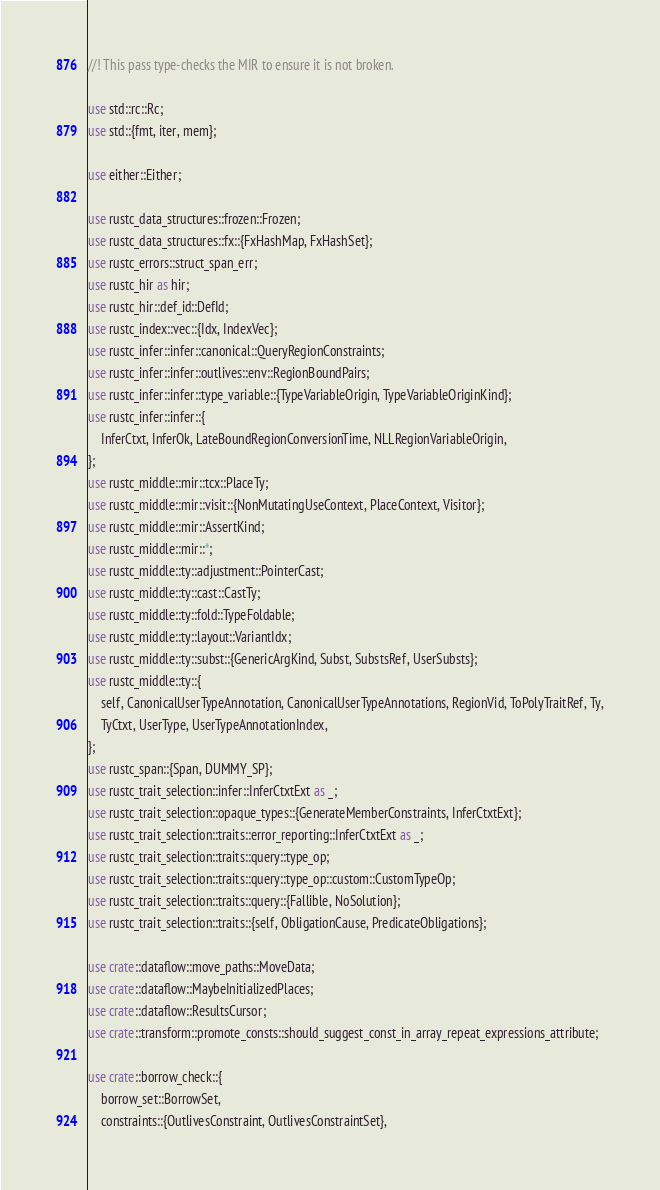Convert code to text. <code><loc_0><loc_0><loc_500><loc_500><_Rust_>//! This pass type-checks the MIR to ensure it is not broken.

use std::rc::Rc;
use std::{fmt, iter, mem};

use either::Either;

use rustc_data_structures::frozen::Frozen;
use rustc_data_structures::fx::{FxHashMap, FxHashSet};
use rustc_errors::struct_span_err;
use rustc_hir as hir;
use rustc_hir::def_id::DefId;
use rustc_index::vec::{Idx, IndexVec};
use rustc_infer::infer::canonical::QueryRegionConstraints;
use rustc_infer::infer::outlives::env::RegionBoundPairs;
use rustc_infer::infer::type_variable::{TypeVariableOrigin, TypeVariableOriginKind};
use rustc_infer::infer::{
    InferCtxt, InferOk, LateBoundRegionConversionTime, NLLRegionVariableOrigin,
};
use rustc_middle::mir::tcx::PlaceTy;
use rustc_middle::mir::visit::{NonMutatingUseContext, PlaceContext, Visitor};
use rustc_middle::mir::AssertKind;
use rustc_middle::mir::*;
use rustc_middle::ty::adjustment::PointerCast;
use rustc_middle::ty::cast::CastTy;
use rustc_middle::ty::fold::TypeFoldable;
use rustc_middle::ty::layout::VariantIdx;
use rustc_middle::ty::subst::{GenericArgKind, Subst, SubstsRef, UserSubsts};
use rustc_middle::ty::{
    self, CanonicalUserTypeAnnotation, CanonicalUserTypeAnnotations, RegionVid, ToPolyTraitRef, Ty,
    TyCtxt, UserType, UserTypeAnnotationIndex,
};
use rustc_span::{Span, DUMMY_SP};
use rustc_trait_selection::infer::InferCtxtExt as _;
use rustc_trait_selection::opaque_types::{GenerateMemberConstraints, InferCtxtExt};
use rustc_trait_selection::traits::error_reporting::InferCtxtExt as _;
use rustc_trait_selection::traits::query::type_op;
use rustc_trait_selection::traits::query::type_op::custom::CustomTypeOp;
use rustc_trait_selection::traits::query::{Fallible, NoSolution};
use rustc_trait_selection::traits::{self, ObligationCause, PredicateObligations};

use crate::dataflow::move_paths::MoveData;
use crate::dataflow::MaybeInitializedPlaces;
use crate::dataflow::ResultsCursor;
use crate::transform::promote_consts::should_suggest_const_in_array_repeat_expressions_attribute;

use crate::borrow_check::{
    borrow_set::BorrowSet,
    constraints::{OutlivesConstraint, OutlivesConstraintSet},</code> 